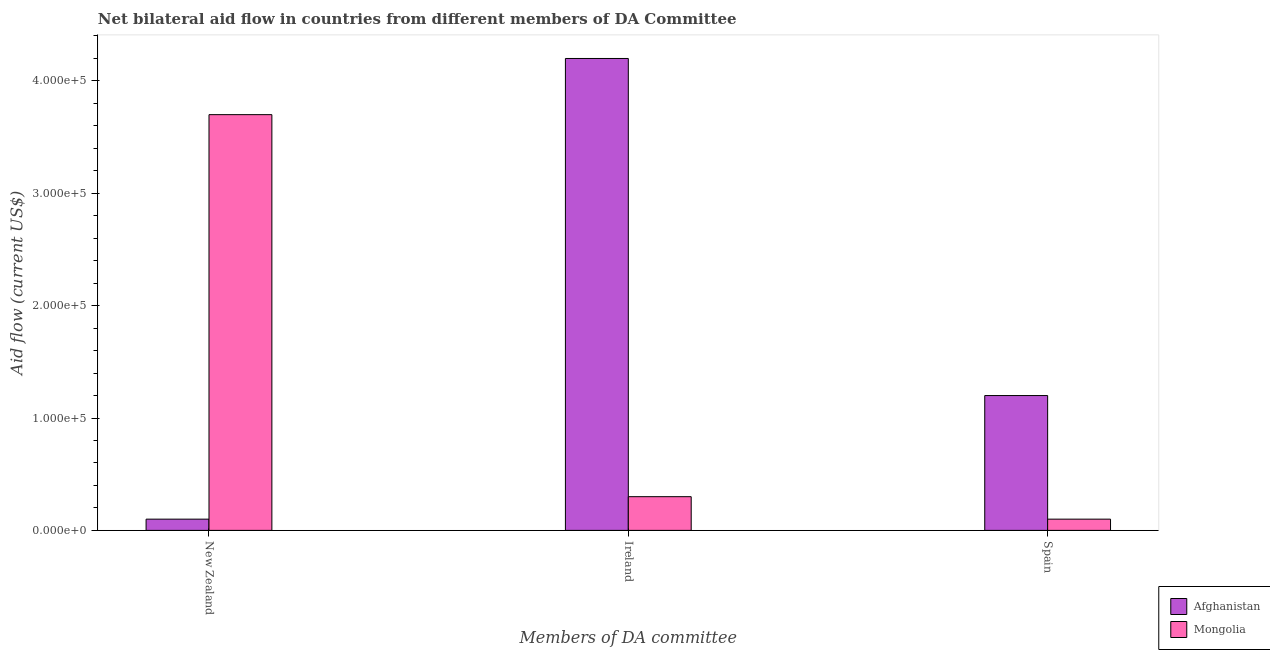How many different coloured bars are there?
Offer a very short reply. 2. How many groups of bars are there?
Give a very brief answer. 3. Are the number of bars on each tick of the X-axis equal?
Give a very brief answer. Yes. How many bars are there on the 2nd tick from the right?
Ensure brevity in your answer.  2. What is the label of the 2nd group of bars from the left?
Provide a succinct answer. Ireland. What is the amount of aid provided by ireland in Afghanistan?
Your response must be concise. 4.20e+05. Across all countries, what is the maximum amount of aid provided by ireland?
Keep it short and to the point. 4.20e+05. Across all countries, what is the minimum amount of aid provided by spain?
Make the answer very short. 10000. In which country was the amount of aid provided by new zealand maximum?
Keep it short and to the point. Mongolia. In which country was the amount of aid provided by ireland minimum?
Ensure brevity in your answer.  Mongolia. What is the total amount of aid provided by new zealand in the graph?
Keep it short and to the point. 3.80e+05. What is the difference between the amount of aid provided by new zealand in Mongolia and that in Afghanistan?
Ensure brevity in your answer.  3.60e+05. What is the difference between the amount of aid provided by new zealand in Mongolia and the amount of aid provided by spain in Afghanistan?
Ensure brevity in your answer.  2.50e+05. What is the average amount of aid provided by new zealand per country?
Your response must be concise. 1.90e+05. What is the difference between the amount of aid provided by new zealand and amount of aid provided by spain in Mongolia?
Give a very brief answer. 3.60e+05. In how many countries, is the amount of aid provided by new zealand greater than 20000 US$?
Give a very brief answer. 1. What is the ratio of the amount of aid provided by spain in Mongolia to that in Afghanistan?
Your response must be concise. 0.08. What is the difference between the highest and the second highest amount of aid provided by new zealand?
Give a very brief answer. 3.60e+05. What is the difference between the highest and the lowest amount of aid provided by new zealand?
Make the answer very short. 3.60e+05. What does the 2nd bar from the left in Spain represents?
Your response must be concise. Mongolia. What does the 1st bar from the right in Spain represents?
Your answer should be compact. Mongolia. How many countries are there in the graph?
Give a very brief answer. 2. Are the values on the major ticks of Y-axis written in scientific E-notation?
Provide a short and direct response. Yes. Does the graph contain any zero values?
Offer a terse response. No. Where does the legend appear in the graph?
Ensure brevity in your answer.  Bottom right. How are the legend labels stacked?
Provide a succinct answer. Vertical. What is the title of the graph?
Your response must be concise. Net bilateral aid flow in countries from different members of DA Committee. Does "Canada" appear as one of the legend labels in the graph?
Offer a terse response. No. What is the label or title of the X-axis?
Give a very brief answer. Members of DA committee. What is the label or title of the Y-axis?
Keep it short and to the point. Aid flow (current US$). What is the Aid flow (current US$) in Afghanistan in New Zealand?
Give a very brief answer. 10000. What is the Aid flow (current US$) of Mongolia in New Zealand?
Keep it short and to the point. 3.70e+05. What is the Aid flow (current US$) of Mongolia in Ireland?
Give a very brief answer. 3.00e+04. What is the Aid flow (current US$) in Afghanistan in Spain?
Provide a short and direct response. 1.20e+05. What is the Aid flow (current US$) in Mongolia in Spain?
Give a very brief answer. 10000. Across all Members of DA committee, what is the minimum Aid flow (current US$) of Afghanistan?
Ensure brevity in your answer.  10000. Across all Members of DA committee, what is the minimum Aid flow (current US$) of Mongolia?
Keep it short and to the point. 10000. What is the total Aid flow (current US$) of Afghanistan in the graph?
Your answer should be very brief. 5.50e+05. What is the total Aid flow (current US$) of Mongolia in the graph?
Make the answer very short. 4.10e+05. What is the difference between the Aid flow (current US$) of Afghanistan in New Zealand and that in Ireland?
Offer a terse response. -4.10e+05. What is the difference between the Aid flow (current US$) in Mongolia in New Zealand and that in Ireland?
Make the answer very short. 3.40e+05. What is the difference between the Aid flow (current US$) of Mongolia in New Zealand and that in Spain?
Offer a very short reply. 3.60e+05. What is the difference between the Aid flow (current US$) of Afghanistan in Ireland and that in Spain?
Make the answer very short. 3.00e+05. What is the difference between the Aid flow (current US$) in Mongolia in Ireland and that in Spain?
Keep it short and to the point. 2.00e+04. What is the difference between the Aid flow (current US$) in Afghanistan in Ireland and the Aid flow (current US$) in Mongolia in Spain?
Offer a terse response. 4.10e+05. What is the average Aid flow (current US$) of Afghanistan per Members of DA committee?
Your answer should be very brief. 1.83e+05. What is the average Aid flow (current US$) in Mongolia per Members of DA committee?
Make the answer very short. 1.37e+05. What is the difference between the Aid flow (current US$) in Afghanistan and Aid flow (current US$) in Mongolia in New Zealand?
Ensure brevity in your answer.  -3.60e+05. What is the ratio of the Aid flow (current US$) of Afghanistan in New Zealand to that in Ireland?
Offer a very short reply. 0.02. What is the ratio of the Aid flow (current US$) of Mongolia in New Zealand to that in Ireland?
Ensure brevity in your answer.  12.33. What is the ratio of the Aid flow (current US$) in Afghanistan in New Zealand to that in Spain?
Offer a very short reply. 0.08. What is the difference between the highest and the second highest Aid flow (current US$) of Afghanistan?
Ensure brevity in your answer.  3.00e+05. What is the difference between the highest and the second highest Aid flow (current US$) of Mongolia?
Provide a succinct answer. 3.40e+05. 